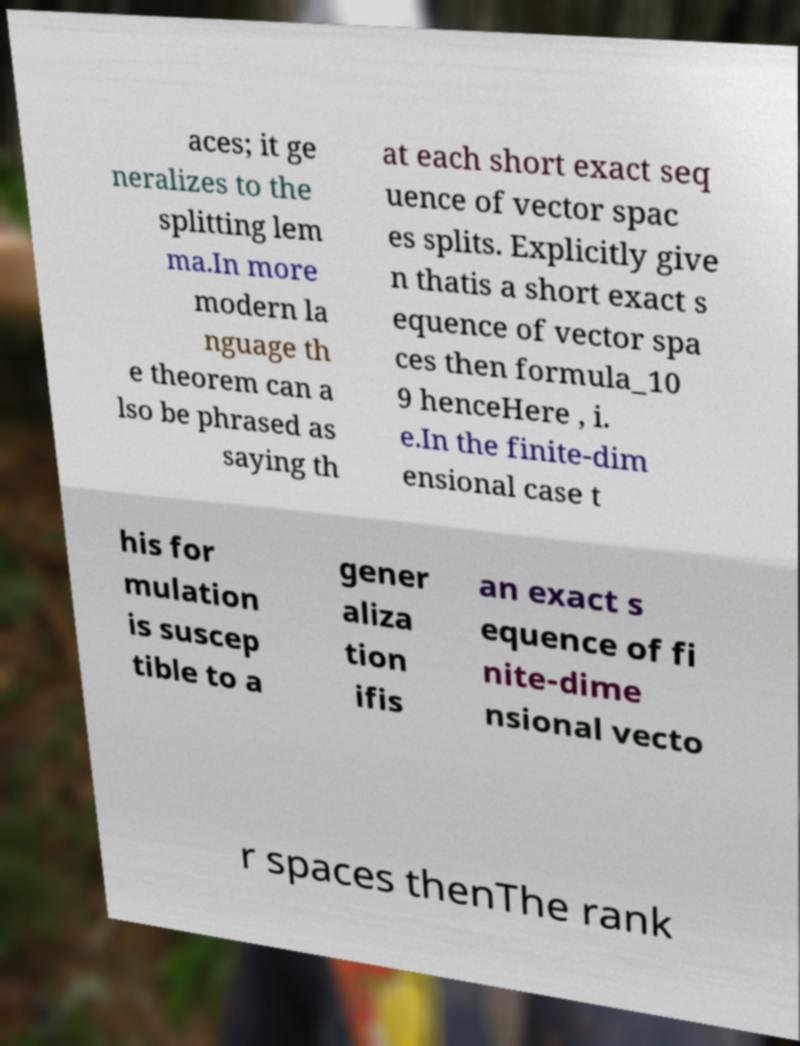I need the written content from this picture converted into text. Can you do that? aces; it ge neralizes to the splitting lem ma.In more modern la nguage th e theorem can a lso be phrased as saying th at each short exact seq uence of vector spac es splits. Explicitly give n thatis a short exact s equence of vector spa ces then formula_10 9 henceHere , i. e.In the finite-dim ensional case t his for mulation is suscep tible to a gener aliza tion ifis an exact s equence of fi nite-dime nsional vecto r spaces thenThe rank 